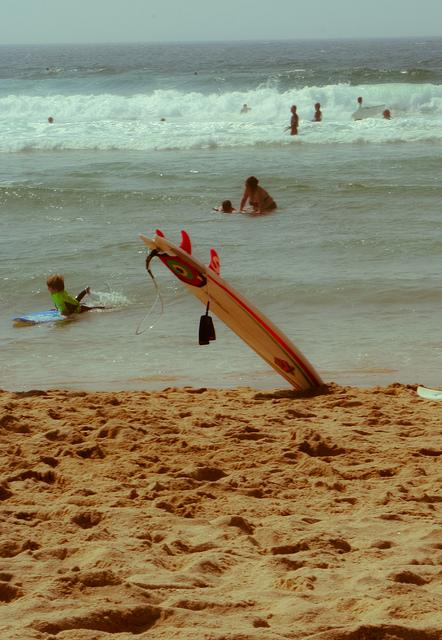What is in the sand? Please explain your reasoning. surfboard. There is a surfboard buried in the sand. 